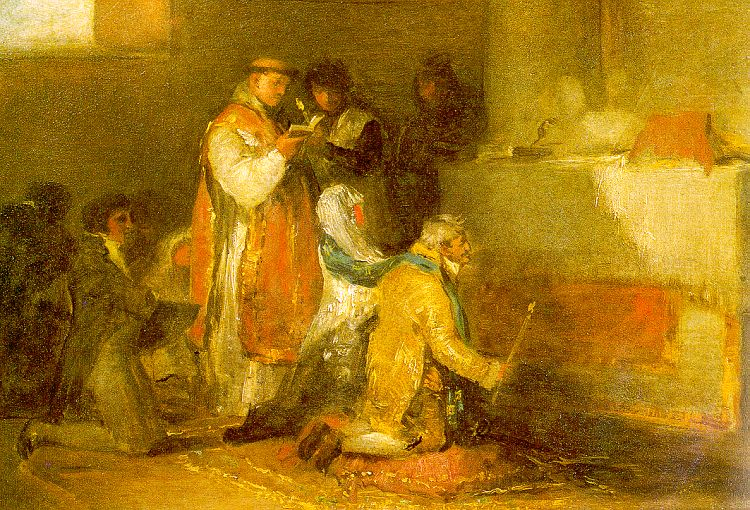Can you describe the significance of the lighting in this painting? The lighting in this impressionist oil painting plays a crucial role in establishing the mood and adding depth to the scene. The artist's use of light emphasizes the central figures, creating a spotlight effect that draws the viewer's attention to them. The interplay of light and shadow enhances the texture of the robes and the surrounding environment. The way the light bathes the room in a soft glow adds to the warm and intimate atmosphere, suggesting a moment frozen in time, full of emotional weight and significance. 